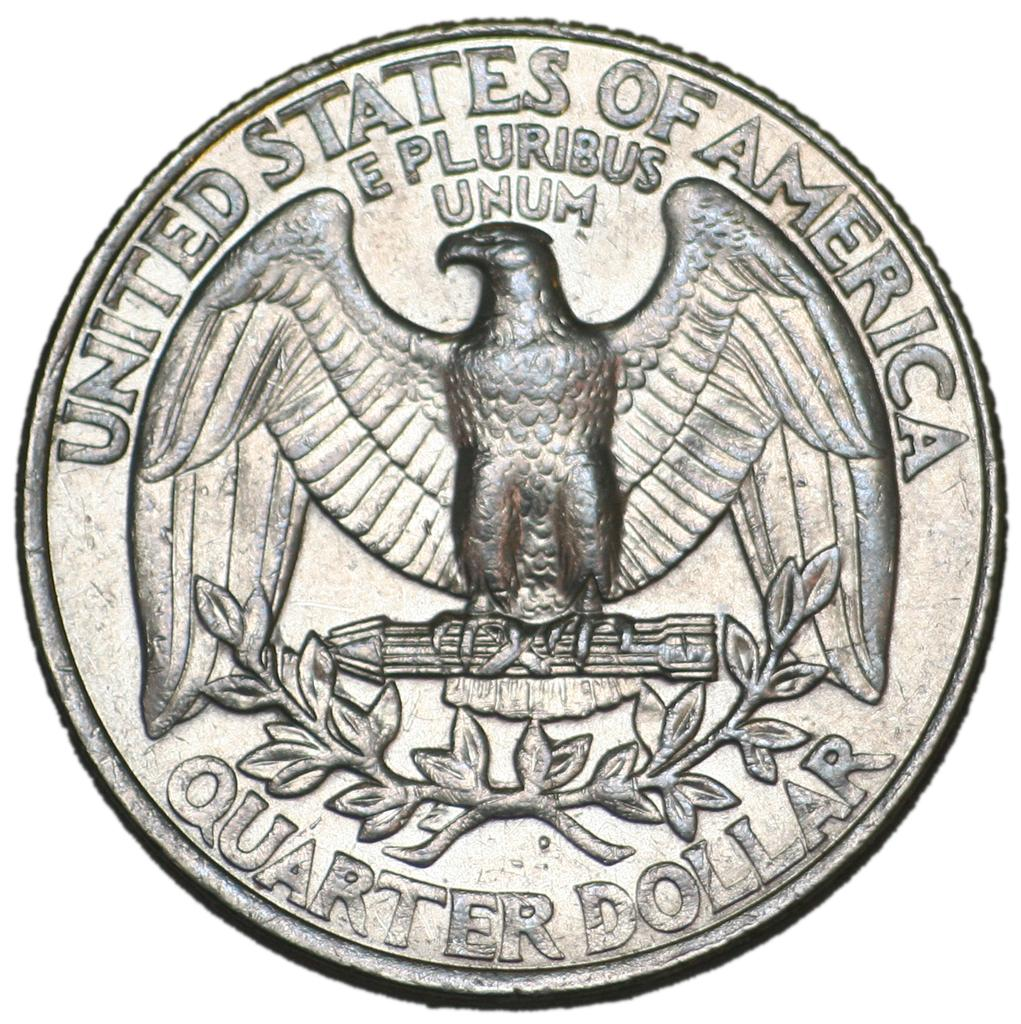What object can be seen in the image? There is a coin in the image. What is written or depicted on the coin? There is text on the coin. How many pizzas are stacked on the tray in the image? There is no tray or pizzas present in the image; it only features a coin with text on it. 